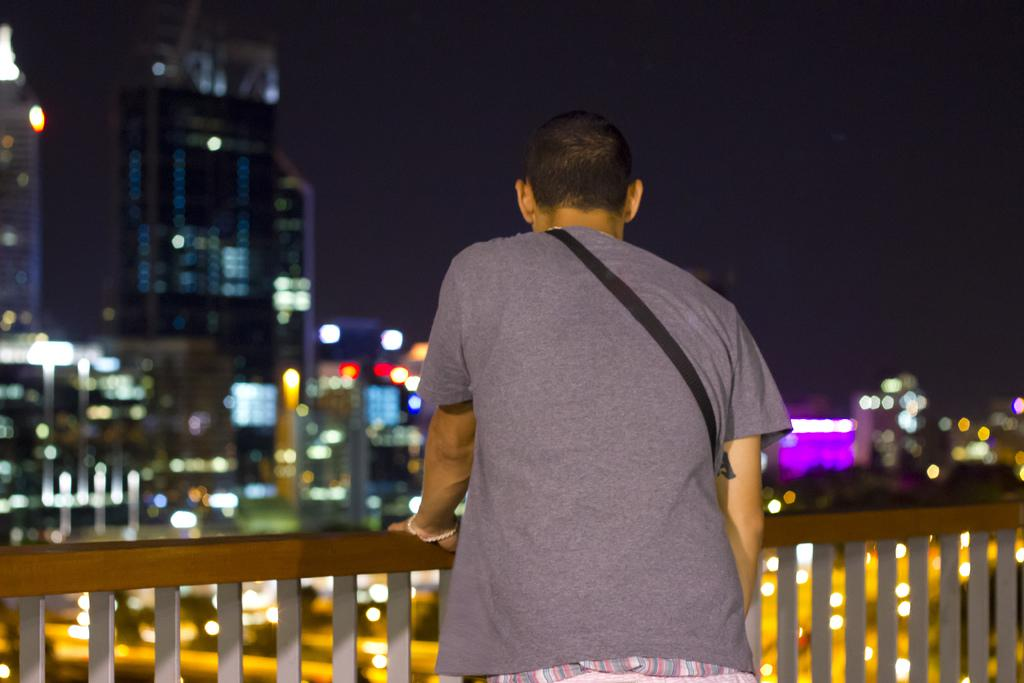What is the man in the image doing? The man is standing at the balcony. What can be seen behind the man? There is a building behind the man. What is visible in the sky in the image? The sky is visible in the image. What color is the man's underwear in the image? There is no information about the man's underwear in the image, so we cannot determine its color. 